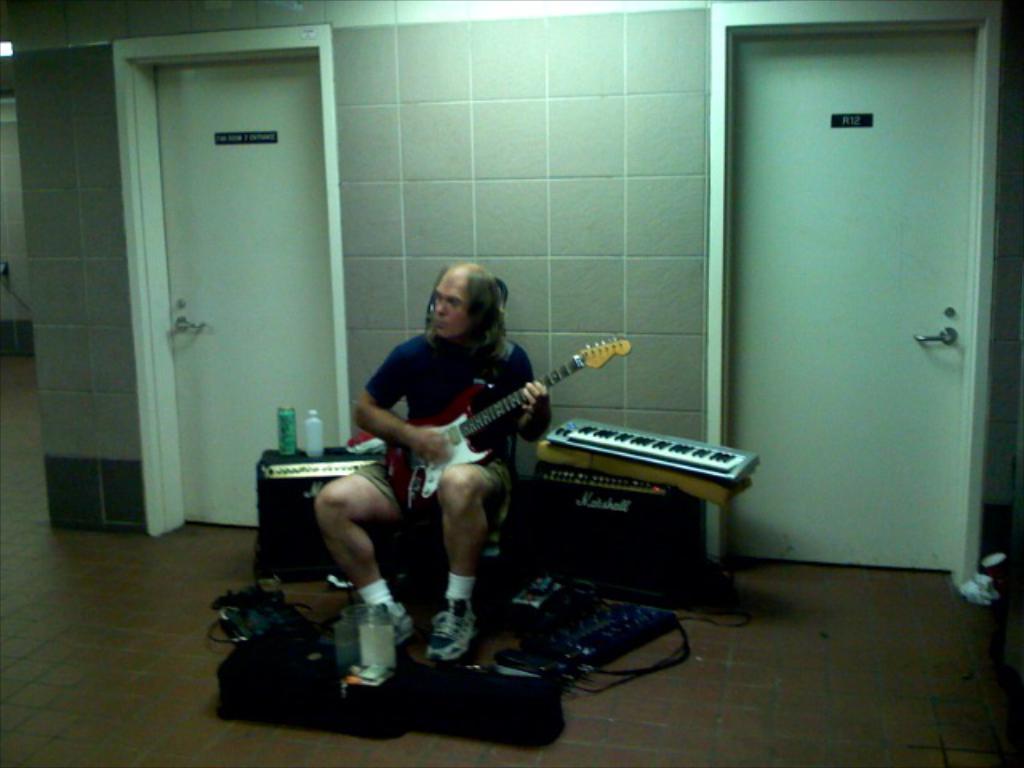Could you give a brief overview of what you see in this image? In this image there is a man who is sitting and playing the guitar. Beside him there is a keyboard which is on the box. At the background there is a wall and door. At the bottom there is a floor on which there is a bag. 